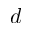<formula> <loc_0><loc_0><loc_500><loc_500>d</formula> 